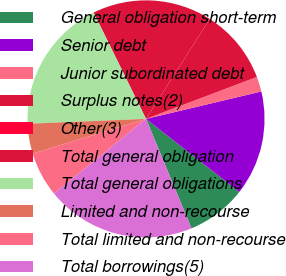Convert chart. <chart><loc_0><loc_0><loc_500><loc_500><pie_chart><fcel>General obligation short-term<fcel>Senior debt<fcel>Junior subordinated debt<fcel>Surplus notes(2)<fcel>Other(3)<fcel>Total general obligation<fcel>Total general obligations<fcel>Limited and non-recourse<fcel>Total limited and non-recourse<fcel>Total borrowings(5)<nl><fcel>8.16%<fcel>14.29%<fcel>2.04%<fcel>10.2%<fcel>0.0%<fcel>16.33%<fcel>18.37%<fcel>4.08%<fcel>6.12%<fcel>20.41%<nl></chart> 